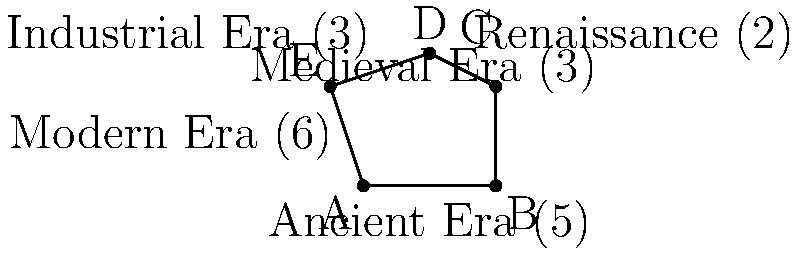A polygon represents different historical eras, with each side length corresponding to the duration of that era in arbitrary units. The Ancient Era is 5 units, the Medieval Era is 3 units, the Renaissance is 2 units, the Industrial Era is 3 units, and the Modern Era is 6 units. Calculate the perimeter of this historical polygon. How might this representation reflect the societal norms and their impact on leadership transitions throughout history? To calculate the perimeter of the polygon, we need to sum the lengths of all sides:

1. Ancient Era: 5 units
2. Medieval Era: 3 units
3. Renaissance: 2 units
4. Industrial Era: 3 units
5. Modern Era: 6 units

Total perimeter = $5 + 3 + 2 + 3 + 6 = 19$ units

This representation can reflect societal norms and their impact on leadership transitions in several ways:

1. The varying lengths of each era suggest that societal norms and leadership styles evolve at different rates throughout history.
2. Shorter sides (e.g., Renaissance) might indicate rapid changes in societal norms and frequent leadership transitions.
3. Longer sides (e.g., Ancient Era, Modern Era) could represent periods of relative stability in societal norms and leadership structures.
4. The overall shape of the polygon might reflect how each era's norms built upon or reacted to the previous ones, influencing the rise and fall of leaders.
5. The perimeter itself could symbolize the cumulative impact of societal changes on leadership throughout history.
Answer: 19 units 